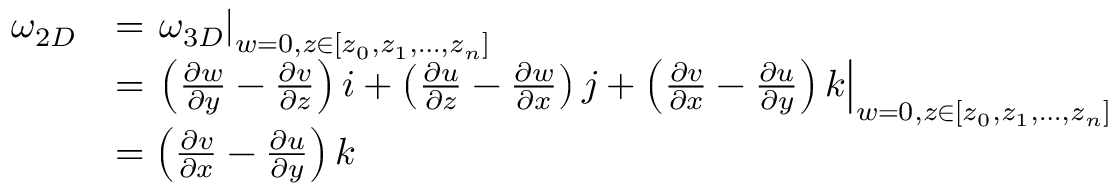Convert formula to latex. <formula><loc_0><loc_0><loc_500><loc_500>\begin{array} { r l } { \omega _ { 2 D } } & { = \omega _ { 3 D } \right | _ { w = 0 , z \in [ z _ { 0 } , z _ { 1 } , \dots , z _ { n } ] } } \\ & { = { \left ( { \frac { \partial w } { \partial y } - \frac { \partial v } { \partial z } } \right ) i + \left ( { \frac { \partial u } { \partial z } - \frac { \partial w } { \partial x } } \right ) j + \left ( { \frac { \partial v } { \partial x } - \frac { \partial u } { \partial y } } \right ) k } \right | _ { w = 0 , z \in [ z _ { 0 } , z _ { 1 } , \dots , z _ { n } ] } } \\ & { = \left ( { \frac { \partial v } { \partial x } - \frac { \partial u } { \partial y } } \right ) k } \end{array}</formula> 